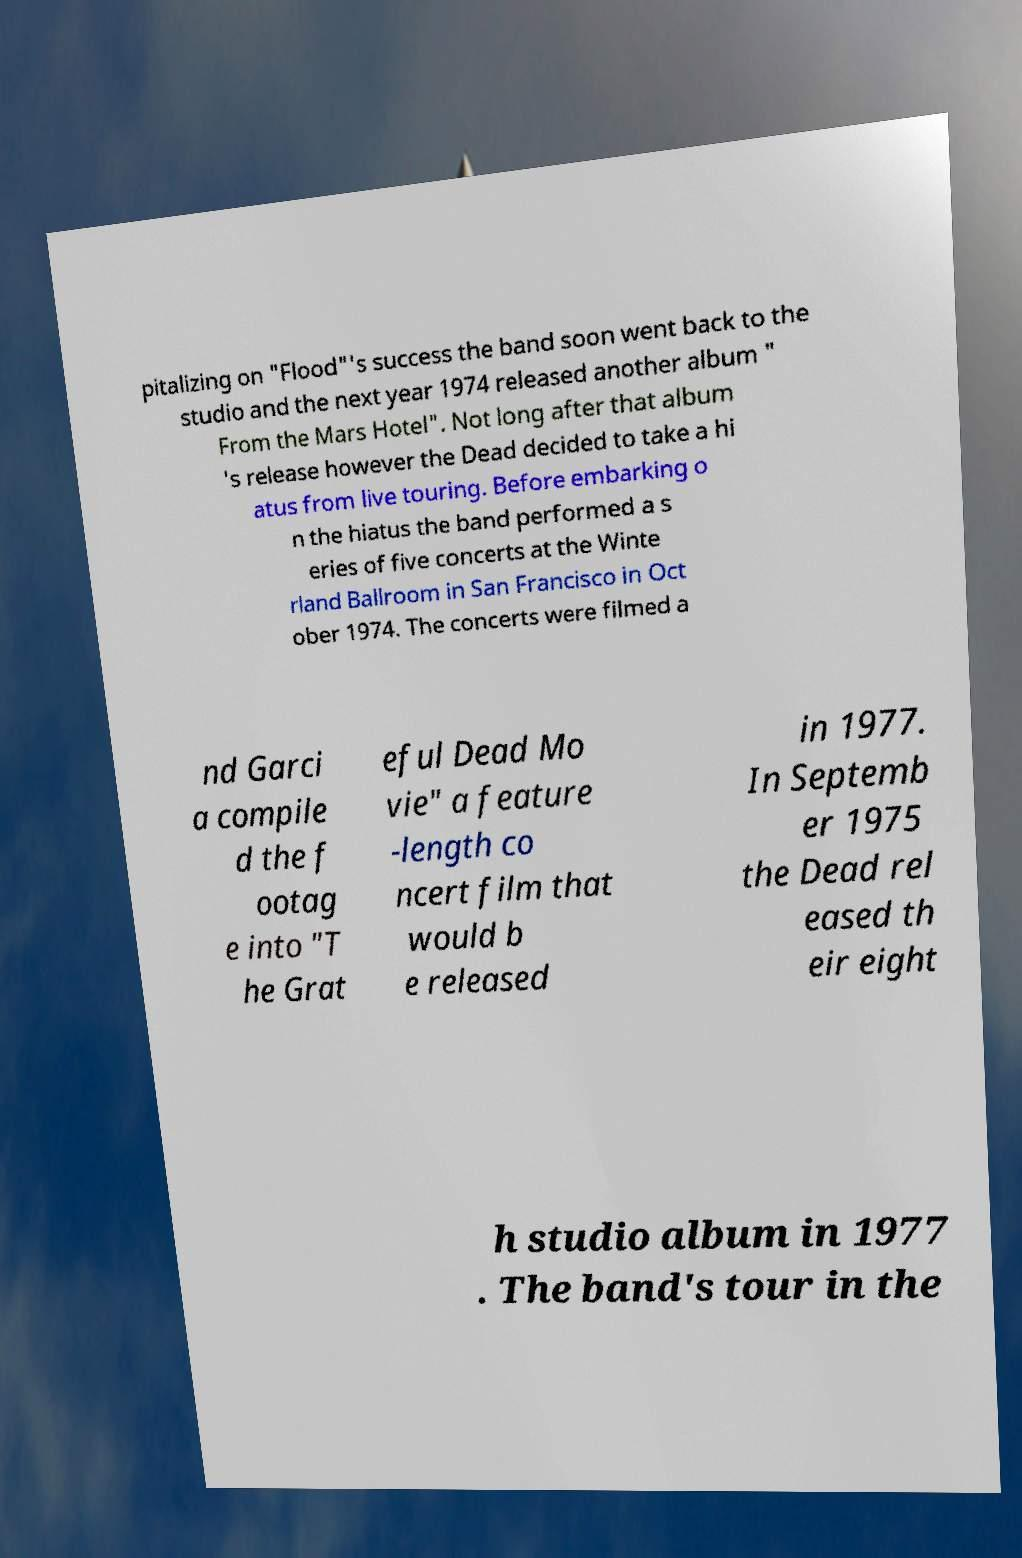For documentation purposes, I need the text within this image transcribed. Could you provide that? pitalizing on "Flood"'s success the band soon went back to the studio and the next year 1974 released another album " From the Mars Hotel". Not long after that album 's release however the Dead decided to take a hi atus from live touring. Before embarking o n the hiatus the band performed a s eries of five concerts at the Winte rland Ballroom in San Francisco in Oct ober 1974. The concerts were filmed a nd Garci a compile d the f ootag e into "T he Grat eful Dead Mo vie" a feature -length co ncert film that would b e released in 1977. In Septemb er 1975 the Dead rel eased th eir eight h studio album in 1977 . The band's tour in the 